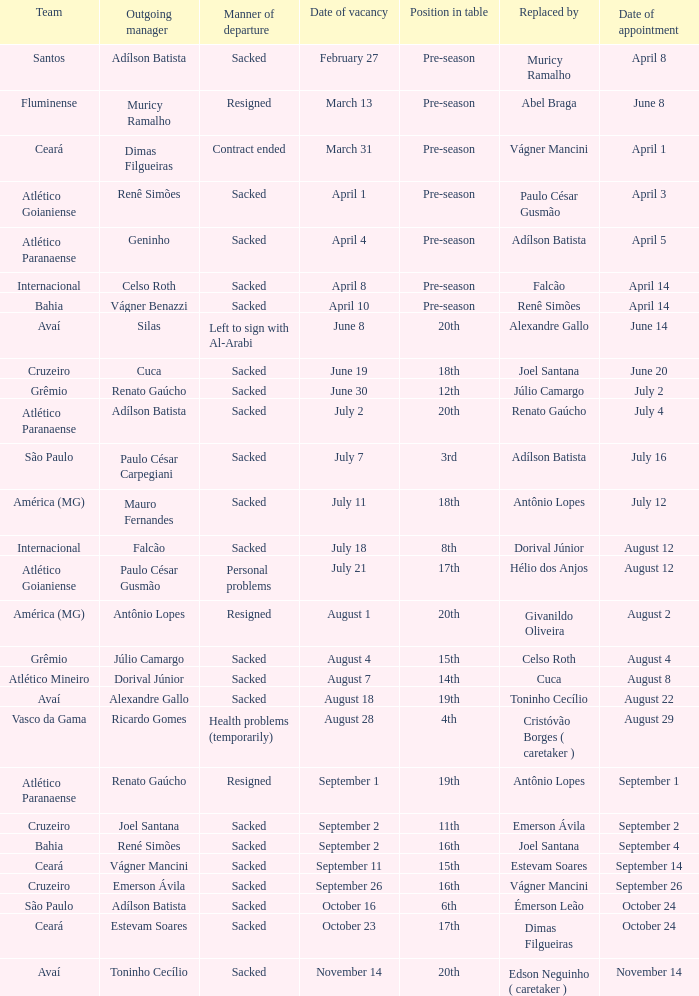How many instances did silas depart as a team manager? 1.0. 